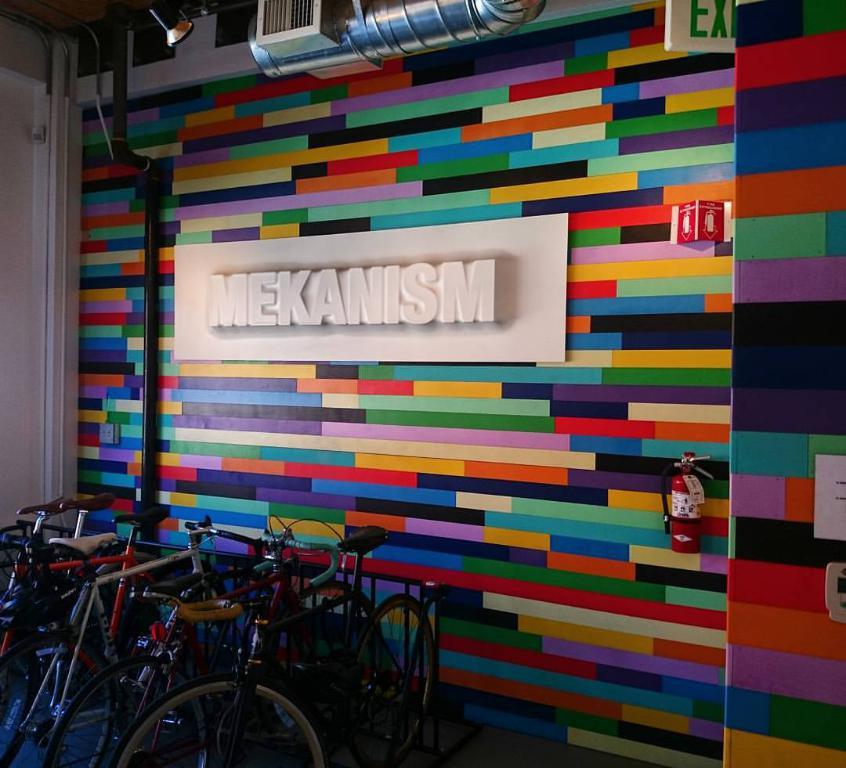<image>
Create a compact narrative representing the image presented. Some bikes are parked in front of a very coloful wall that says, "MEKANISM". 